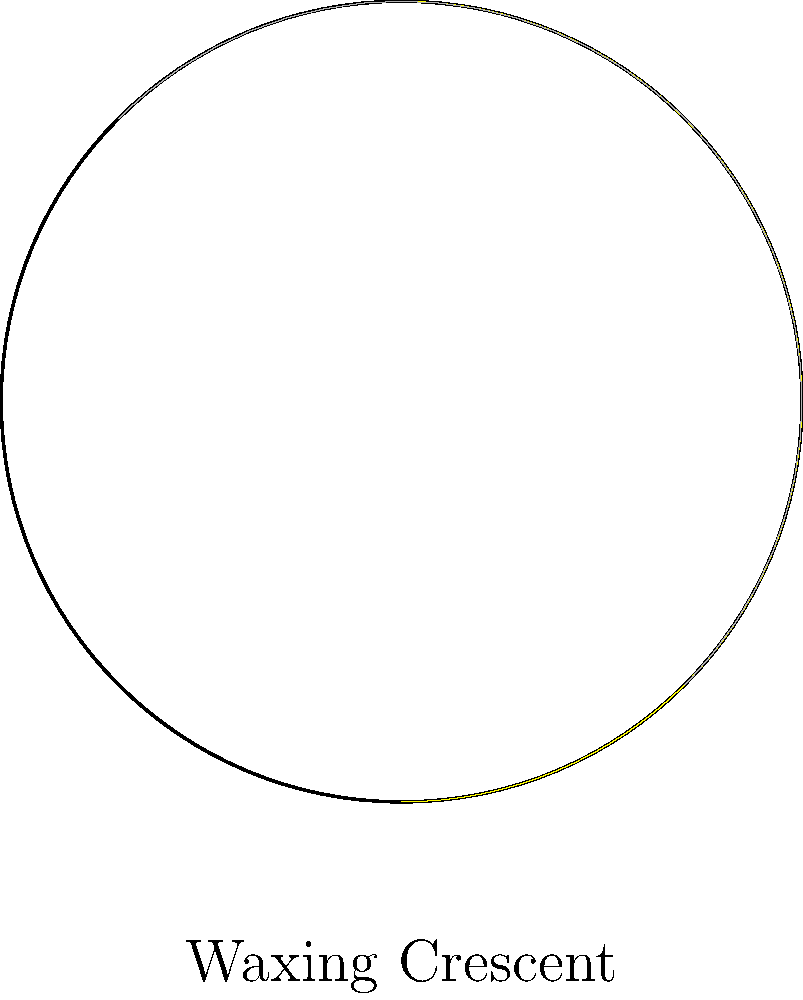Based on the circular diagram representing a phase of the moon, what is the name of this lunar phase? To identify the moon phase from the circular diagram, follow these steps:

1. Observe the illuminated portion of the moon:
   - The yellow area represents the illuminated part.
   - The gray area represents the dark part.

2. Determine the direction of illumination:
   - The right side of the moon is illuminated.
   - This indicates that the moon is in a waxing phase (growing more illuminated).

3. Estimate the amount of illumination:
   - Less than half of the moon's surface is illuminated.
   - The crescent shape is visible on the right side.

4. Combine the observations:
   - Waxing (growing more illuminated) + Crescent shape = Waxing Crescent

5. Confirm with the label:
   - The diagram is labeled "Waxing Crescent," which matches our analysis.

Therefore, the lunar phase represented in this circular diagram is the Waxing Crescent.
Answer: Waxing Crescent 